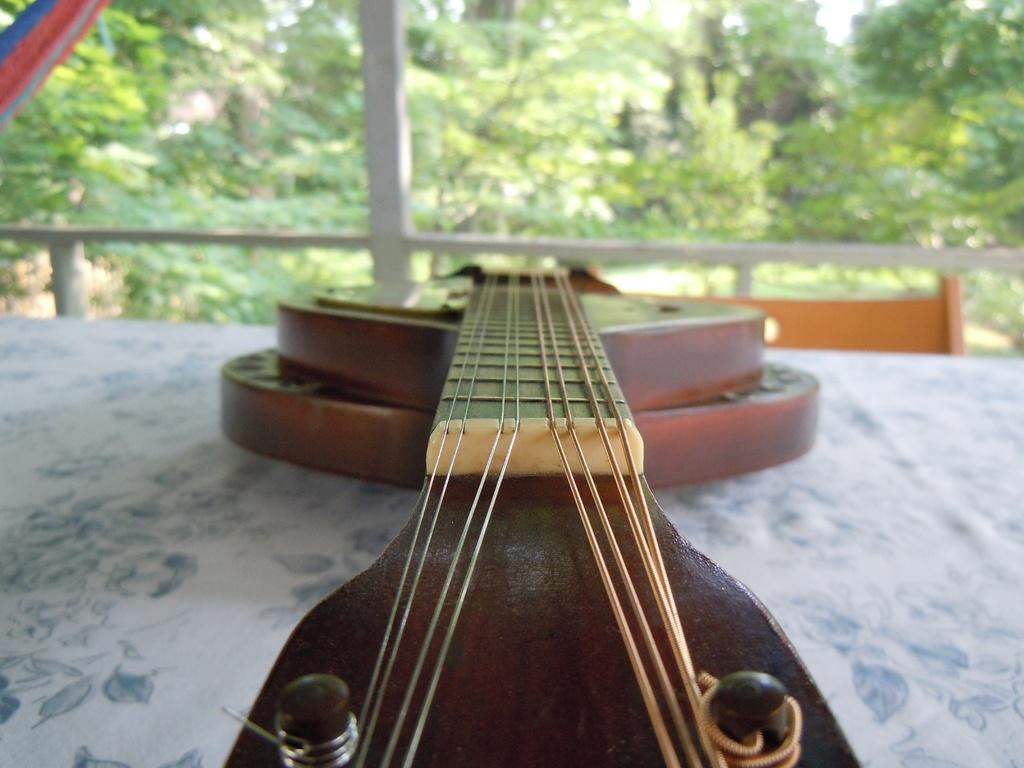Please provide a concise description of this image. There is a table with white color cloth and guitar on it and a chair in front of the table. In the background there are some trees. 